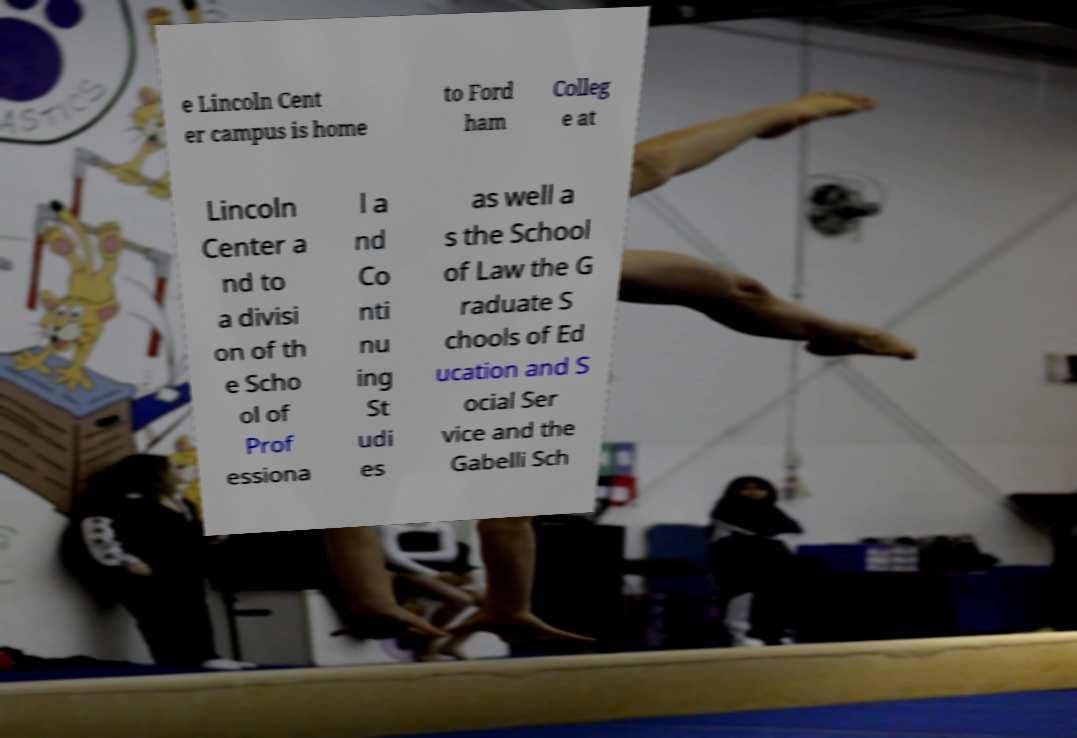Please identify and transcribe the text found in this image. e Lincoln Cent er campus is home to Ford ham Colleg e at Lincoln Center a nd to a divisi on of th e Scho ol of Prof essiona l a nd Co nti nu ing St udi es as well a s the School of Law the G raduate S chools of Ed ucation and S ocial Ser vice and the Gabelli Sch 